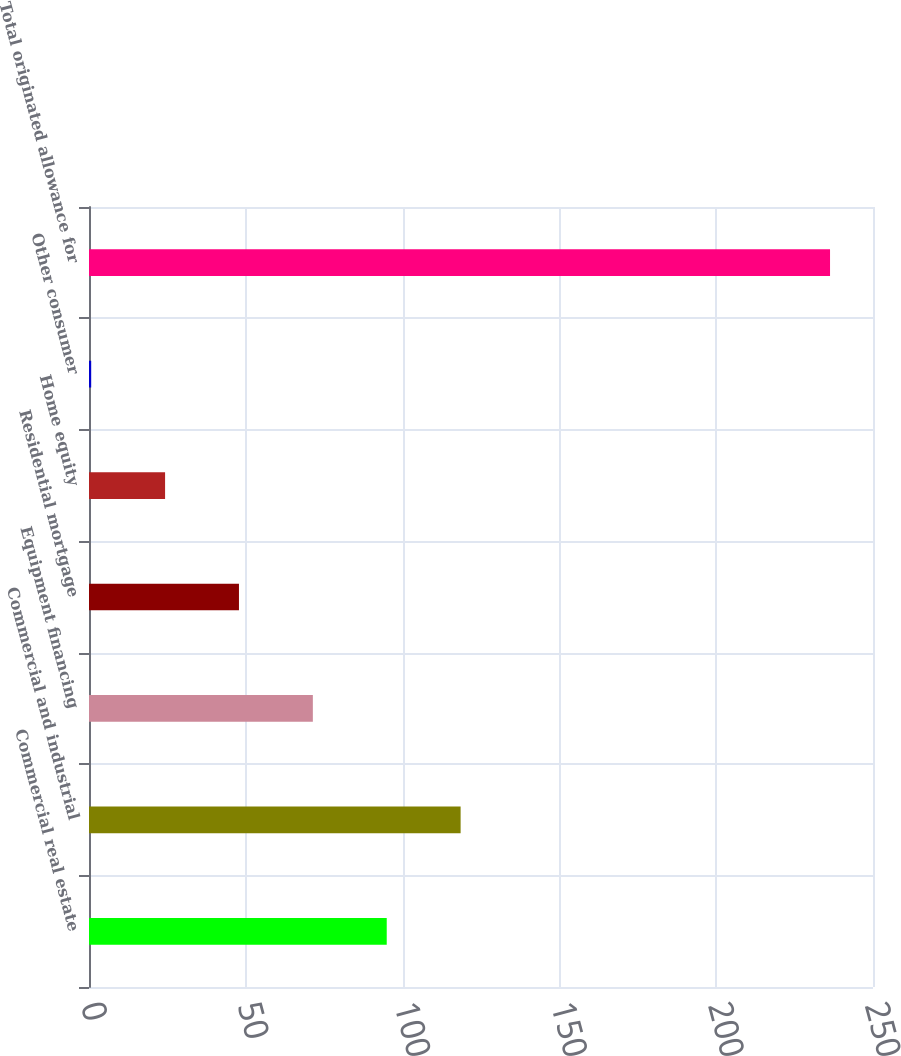Convert chart. <chart><loc_0><loc_0><loc_500><loc_500><bar_chart><fcel>Commercial real estate<fcel>Commercial and industrial<fcel>Equipment financing<fcel>Residential mortgage<fcel>Home equity<fcel>Other consumer<fcel>Total originated allowance for<nl><fcel>94.94<fcel>118.5<fcel>71.38<fcel>47.82<fcel>24.26<fcel>0.7<fcel>236.3<nl></chart> 